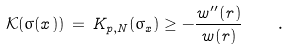Convert formula to latex. <formula><loc_0><loc_0><loc_500><loc_500>\mathcal { K } ( \sigma ( x ) ) \, = \, K _ { p , N } ( \sigma _ { x } ) \geq - \frac { w ^ { \prime \prime } ( r ) } { w ( r ) } \quad .</formula> 